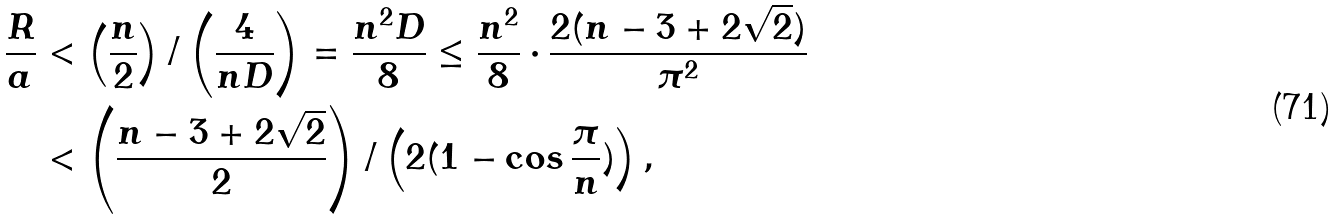Convert formula to latex. <formula><loc_0><loc_0><loc_500><loc_500>\frac { R } { a } & < \left ( \frac { n } { 2 } \right ) / \left ( \frac { 4 } { n D } \right ) = \frac { n ^ { 2 } D } { 8 } \leq \frac { n ^ { 2 } } { 8 } \cdot \frac { 2 ( n - 3 + 2 \sqrt { 2 } ) } { \pi ^ { 2 } } \\ & < \left ( \frac { n - 3 + 2 \sqrt { 2 } } { 2 } \right ) / \left ( 2 ( 1 - \cos { \frac { \pi } { n } } ) \right ) ,</formula> 